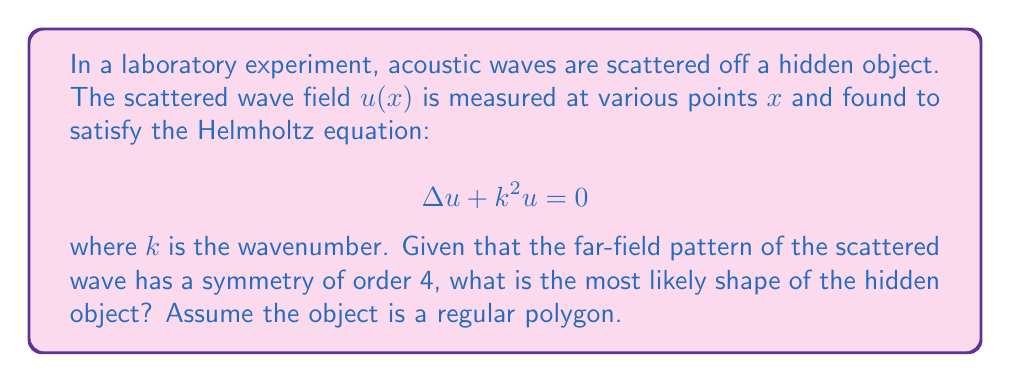Give your solution to this math problem. 1. The Helmholtz equation describes wave propagation in a medium. In this case, it represents the acoustic waves scattering off the hidden object.

2. The far-field pattern of the scattered wave provides information about the shape of the scattering object.

3. Symmetry of order 4 means that the far-field pattern repeats every 90 degrees (360° / 4 = 90°).

4. Regular polygons with 4-fold rotational symmetry include:
   - Square (4 sides)
   - Octagon (8 sides)
   - Any regular polygon with 4n sides, where n is a positive integer

5. Among these options, the square is the simplest and most likely shape, given the limited information provided.

6. More complex shapes (like octagons) would typically produce more complex scattering patterns, which are not indicated in the problem statement.

Therefore, the most likely shape of the hidden object is a square.
Answer: Square 